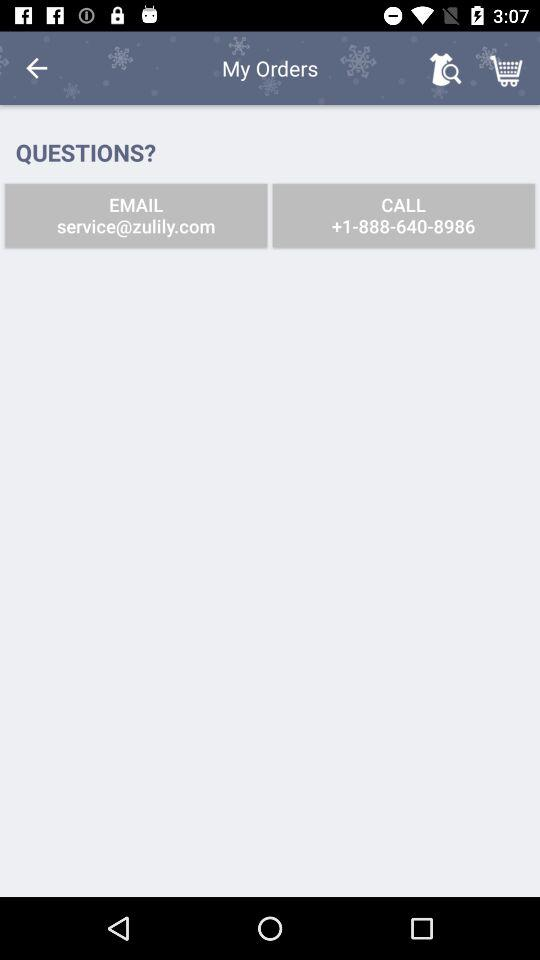What is the email address? The email address is service@zulily.com. 